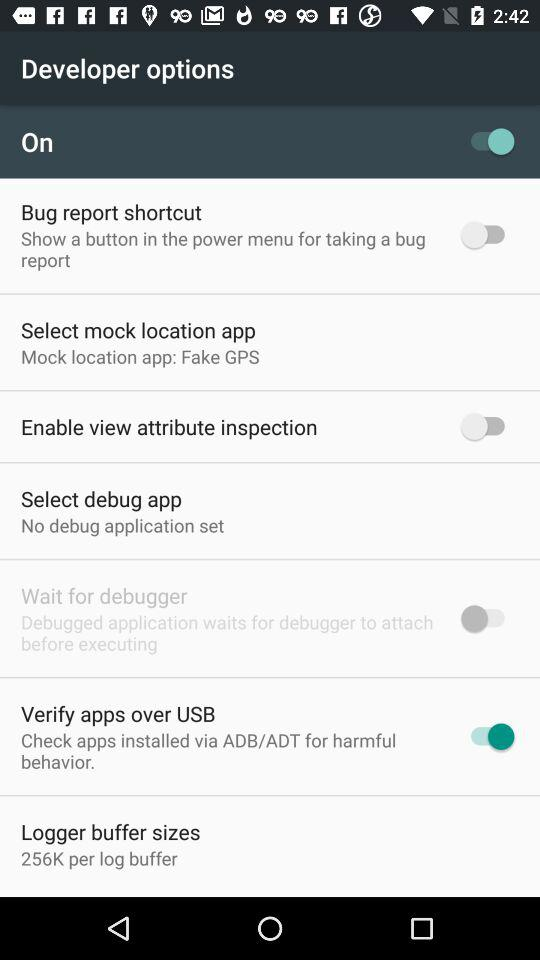What is the status of the "Enable view attribute inspection"? The status is "off". 